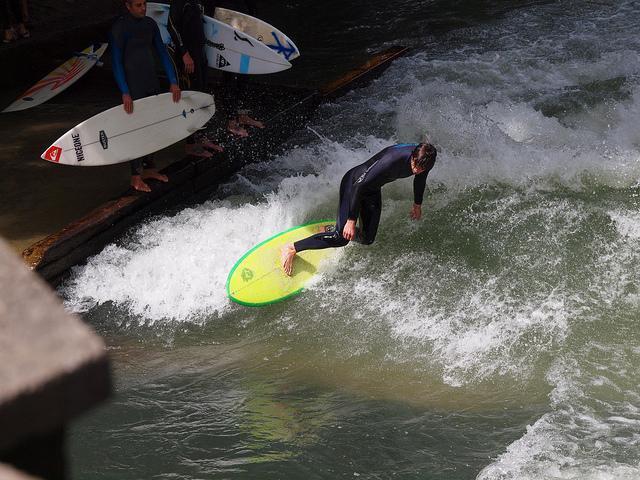How many surfboards are there?
Give a very brief answer. 5. How many boards in the water?
Give a very brief answer. 1. How many people are visible?
Give a very brief answer. 3. How many surfboards are in the photo?
Give a very brief answer. 4. How many giraffes are there standing in the sun?
Give a very brief answer. 0. 